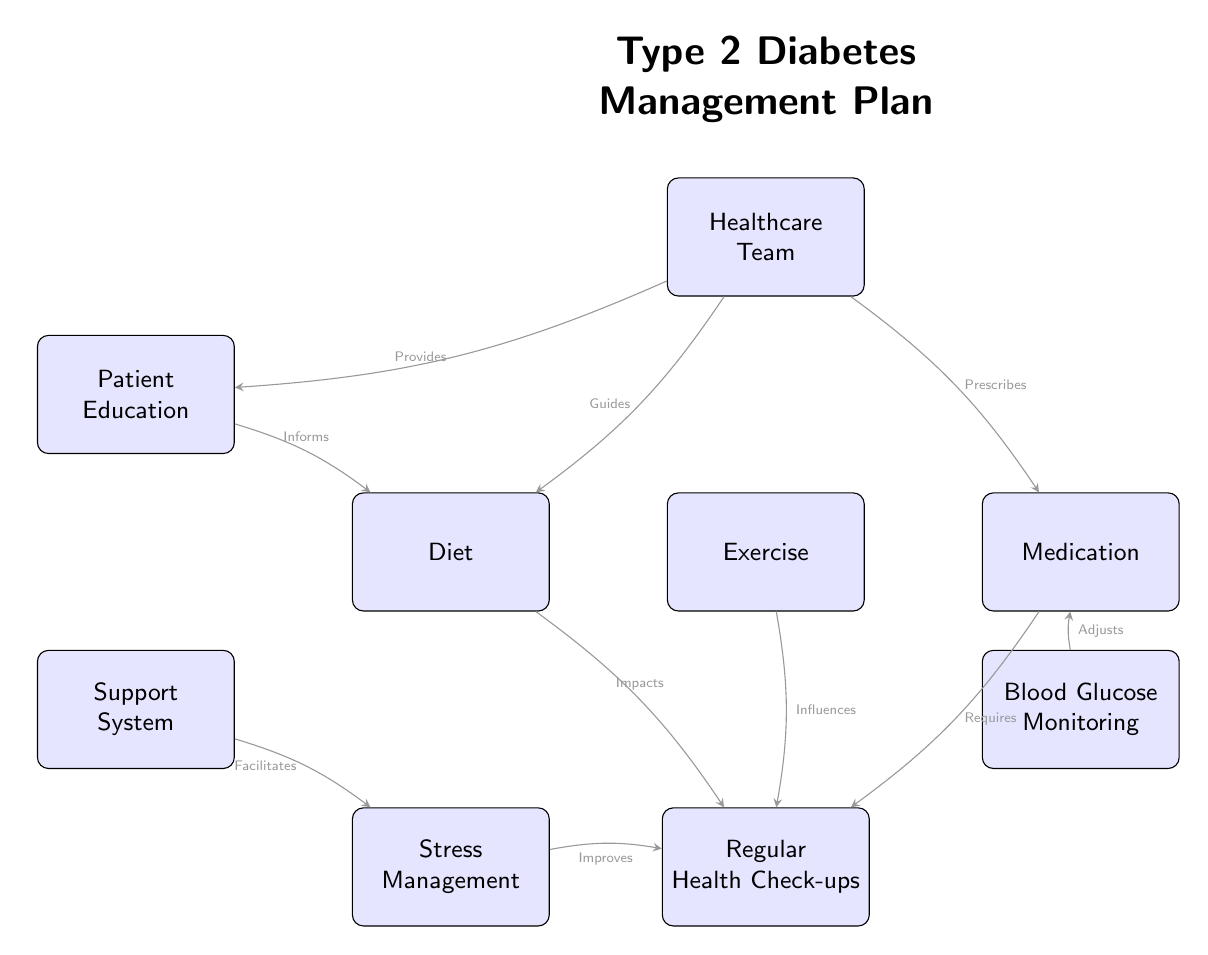What are the main components of the diabetes management plan? The diagram includes six main components represented by nodes: Diet, Exercise, Medication, Regular Health Check-ups, Blood Glucose Monitoring, Patient Education, Support System, Stress Management, and Healthcare Team.
Answer: Diet, Exercise, Medication, Regular Health Check-ups, Blood Glucose Monitoring, Patient Education, Support System, Stress Management, Healthcare Team How many nodes are present in the diagram? The diagram shows a total of ten nodes that represent various aspects of the diabetes management plan.
Answer: Ten Which component influences the Regular Health Check-ups according to the diagram? The diagram indicates that both Exercise and Diet influence Regular Health Check-ups, as represented by the arrows connecting them.
Answer: Exercise, Diet What role does the Healthcare Team play in the diabetes management workflow? The diagram outlines that the Healthcare Team guides Diet, prescribes Medication, and provides Education, denoting their supportive role in management.
Answer: Guides Diet, Prescribes Medication, Provides Education How does Blood Glucose Monitoring relate to Medication in this workflow? According to the diagram, Blood Glucose Monitoring adjusts Medication, implying that monitoring influences how medication is managed.
Answer: Adjusts Medication What impact does Stress Management have on Regular Health Check-ups? The diagram indicates that Stress Management improves Regular Health Check-ups, showing a positive relationship between managing stress and health evaluations.
Answer: Improves Regular Health Check-ups Which component informs Diet in the diabetes management process? The relationship shown in the diagram indicates that Patient Education informs Diet, meaning that education significantly impacts dietary choices.
Answer: Patient Education What is the interaction between Support System and Stress Management? The diagram indicates that the Support System facilitates Stress Management, suggesting that having support helps in managing stress effectively.
Answer: Facilitates Stress Management 